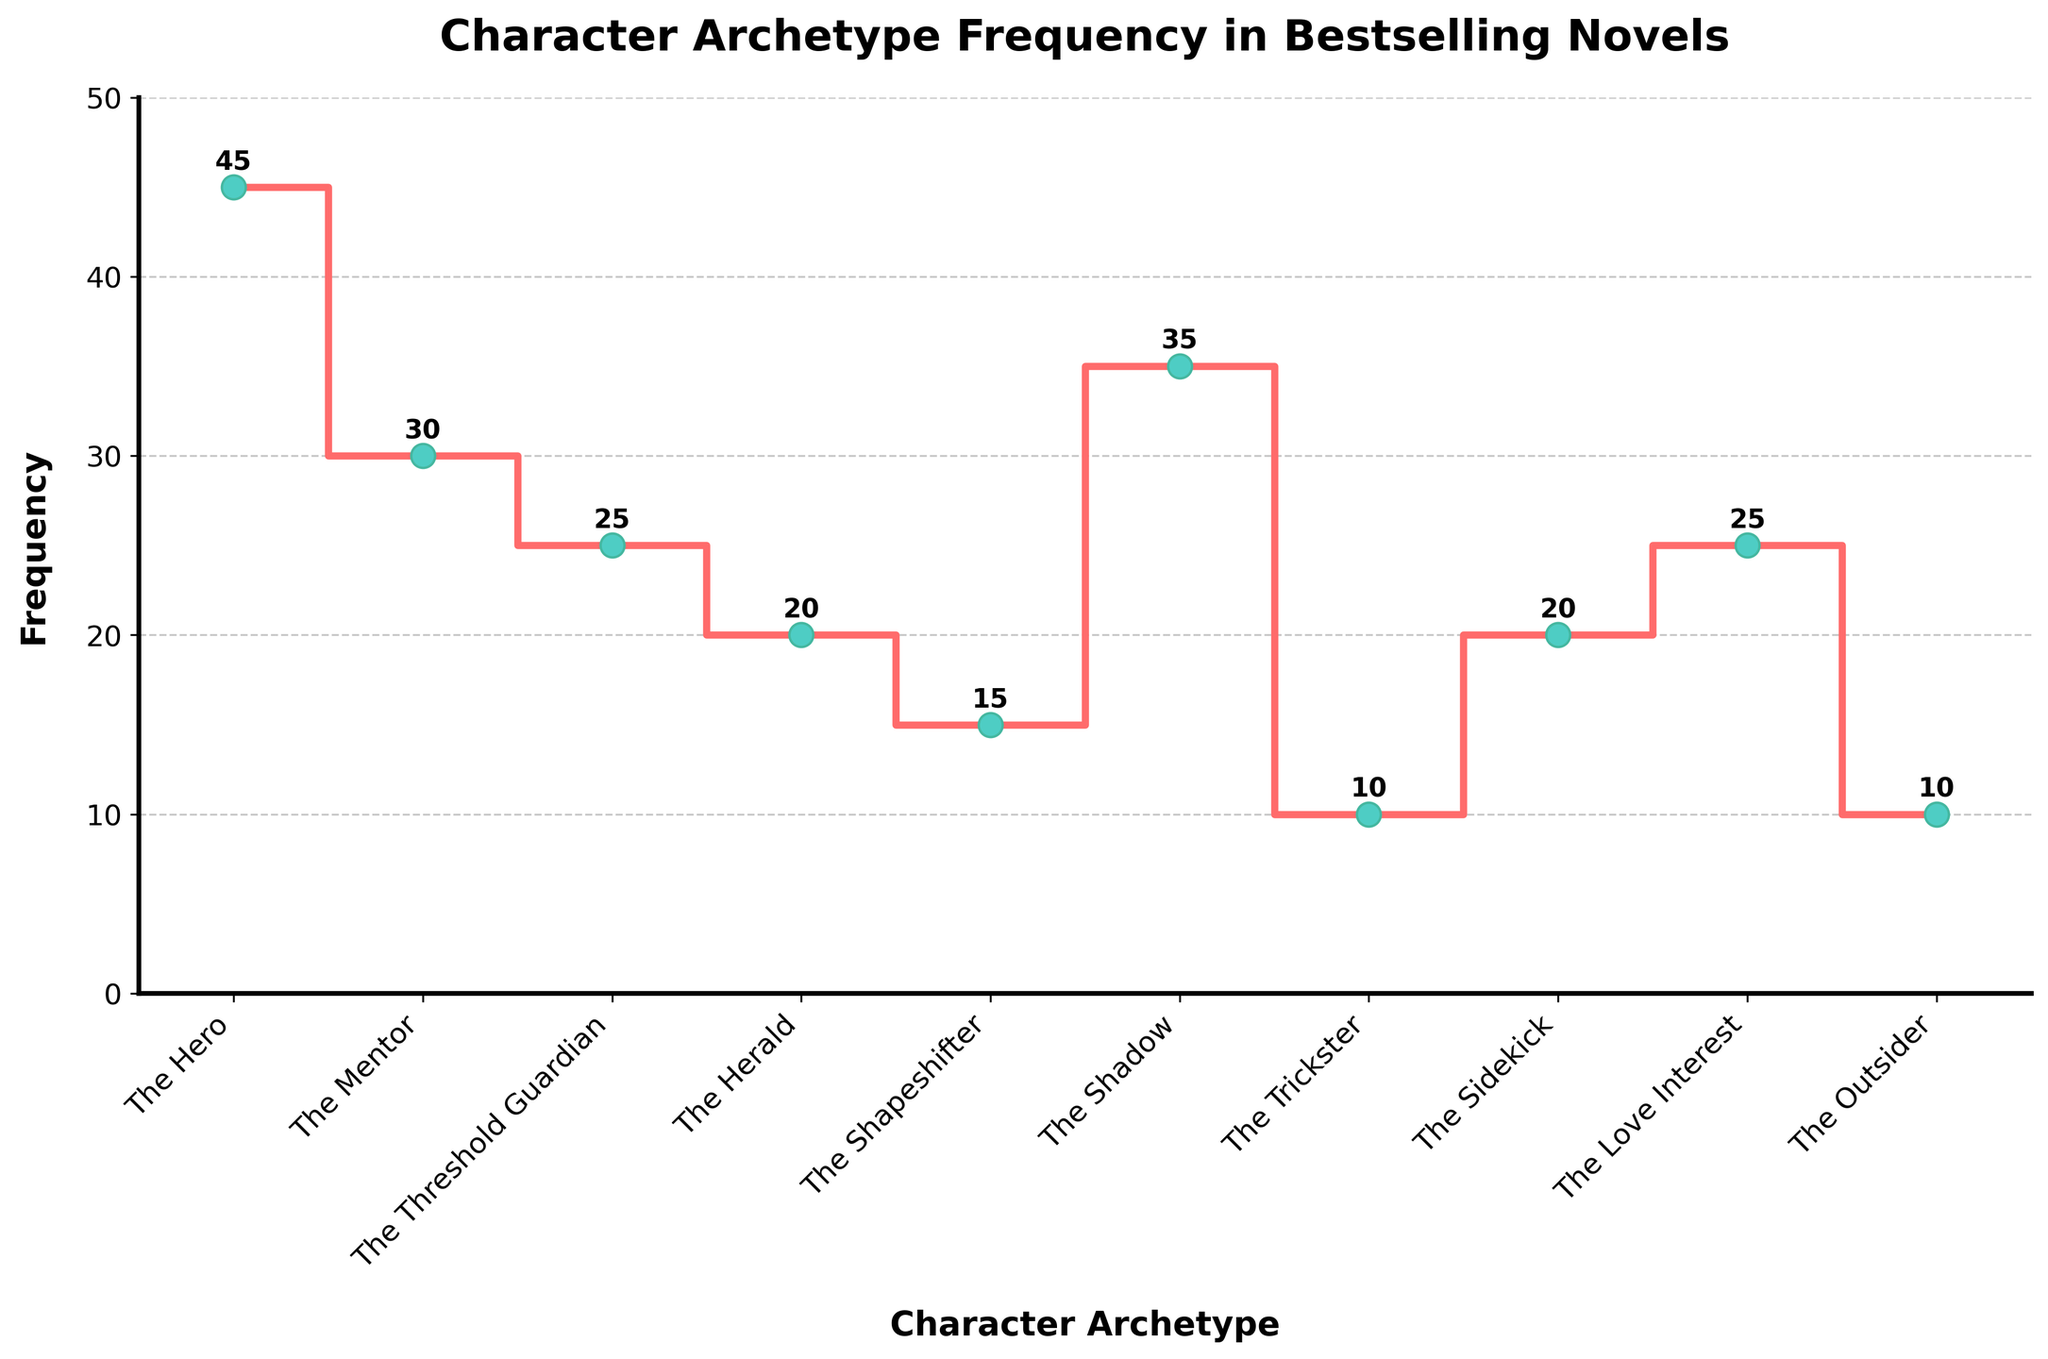What's the title of the figure? The title is prominently displayed at the top of the figure.
Answer: Character Archetype Frequency in Bestselling Novels What character archetype has the highest frequency? The figure shows the number of times each character archetype appears, with the highest point on the y-axis corresponding to 'The Hero'.
Answer: The Hero Which two character archetypes have the same frequency? By visually inspecting the y-values of different character archetypes, 'The Threshold Guardian' and 'The Love Interest' both have a frequency of 25.
Answer: The Threshold Guardian and The Love Interest What's the difference in frequency between 'The Hero' and 'The Trickster'? 'The Hero' has a frequency of 45, and 'The Trickster' has a frequency of 10. Subtracting the Trickster's frequency from the Hero's gives 45 - 10.
Answer: 35 How many character archetypes have frequencies greater than 20? By counting the character archetypes with frequencies above 20 (The Hero, The Mentor, The Shadow, The Threshold Guardian, The Love Interest), we find there are 5.
Answer: 5 What is the frequency of 'The Shapeshifter'? The figure marks the frequency directly above the data point for 'The Shapeshifter'.
Answer: 15 Which character archetype has the lowest frequency? The lowest point on the y-axis corresponds to 'The Trickster' and 'The Outsider', both of which have the lowest value.
Answer: The Trickster and The Outsider How many character archetypes are represented in the figure? By counting the distinct labels on the x-axis, we find there are 10 character archetypes.
Answer: 10 Which character archetype has a frequency closest to the average frequency? First, calculate the average frequency: (45 + 30 + 25 + 20 + 15 + 35 + 10 + 20 + 25 + 10) / 10 = 235 / 10 = 23.5. 'The Mentor' has a frequency of 30 which is closest to 23.5.
Answer: The Mentor What is the combined frequency of 'The Herald' and 'The Sidekick'? The figure shows the frequency for 'The Herald' as 20 and 'The Sidekick' as 20. Adding these together gives 20 + 20.
Answer: 40 